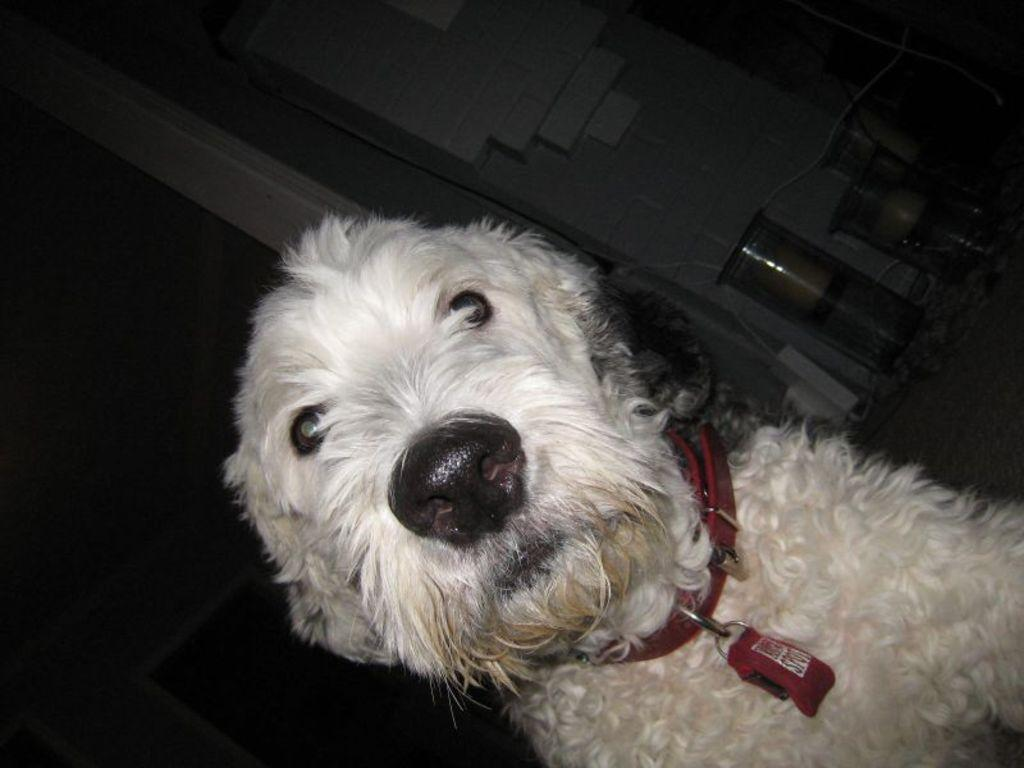What type of animal is in the image? There is a dog in the image. What color is the dog? The dog is white. Can you describe the background of the image? There are objects in the background of the image. What colors are present on the wall in the background? The wall in the background is in cream and white color. What type of base is supporting the chair in the image? There is no chair present in the image, so it is not possible to determine what type of base supports it. 